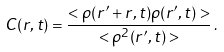Convert formula to latex. <formula><loc_0><loc_0><loc_500><loc_500>C ( r , t ) = \frac { < \rho ( { r ^ { \prime } } + { r } , t ) \rho ( { r ^ { \prime } } , t ) > } { < \rho ^ { 2 } ( { r ^ { \prime } } , t ) > } \, .</formula> 